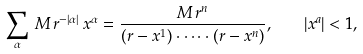Convert formula to latex. <formula><loc_0><loc_0><loc_500><loc_500>\sum _ { \alpha } \, M \, r ^ { - | \alpha | } \, x ^ { \alpha } = \frac { M \, r ^ { n } } { ( r - x ^ { 1 } ) \cdot \dots \cdot ( r - x ^ { n } ) } , \quad | x ^ { a } | < 1 ,</formula> 